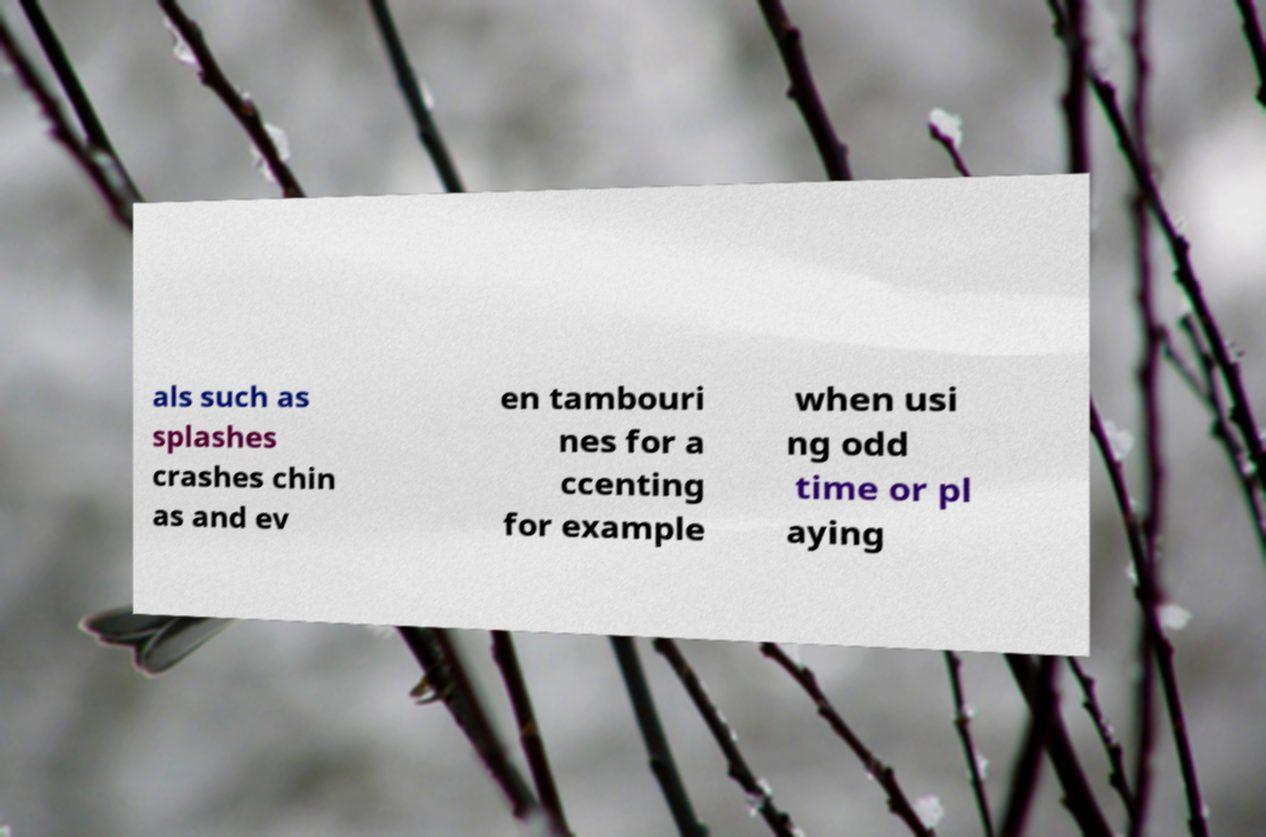There's text embedded in this image that I need extracted. Can you transcribe it verbatim? als such as splashes crashes chin as and ev en tambouri nes for a ccenting for example when usi ng odd time or pl aying 